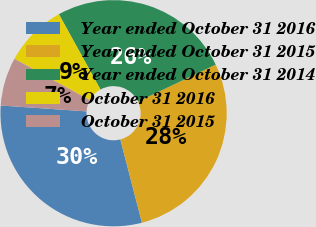Convert chart. <chart><loc_0><loc_0><loc_500><loc_500><pie_chart><fcel>Year ended October 31 2016<fcel>Year ended October 31 2015<fcel>Year ended October 31 2014<fcel>October 31 2016<fcel>October 31 2015<nl><fcel>30.12%<fcel>28.04%<fcel>25.96%<fcel>8.98%<fcel>6.9%<nl></chart> 